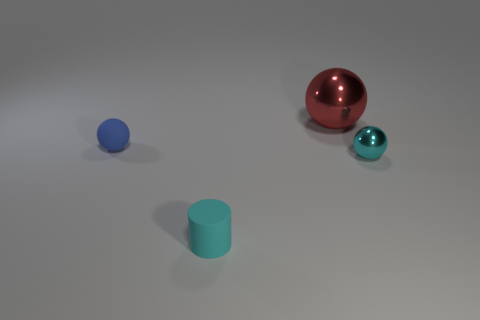What material is the big thing?
Your answer should be very brief. Metal. How many objects have the same material as the blue ball?
Offer a terse response. 1. What number of metal things are either big balls or spheres?
Make the answer very short. 2. There is a thing left of the small cylinder; does it have the same shape as the rubber object in front of the tiny blue object?
Your response must be concise. No. What is the color of the object that is left of the big red object and behind the cyan shiny ball?
Give a very brief answer. Blue. Do the sphere to the left of the large ball and the shiny sphere right of the large red thing have the same size?
Ensure brevity in your answer.  Yes. How many big shiny cubes have the same color as the small cylinder?
Ensure brevity in your answer.  0. What number of tiny things are either shiny cubes or red metal balls?
Your answer should be very brief. 0. Does the cyan object left of the tiny cyan ball have the same material as the large red thing?
Provide a short and direct response. No. There is a small matte thing that is behind the cyan cylinder; what is its color?
Give a very brief answer. Blue. 